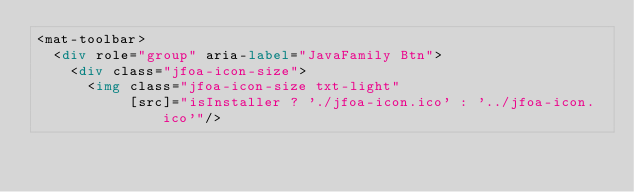<code> <loc_0><loc_0><loc_500><loc_500><_HTML_><mat-toolbar>
  <div role="group" aria-label="JavaFamily Btn">
    <div class="jfoa-icon-size">
      <img class="jfoa-icon-size txt-light"
           [src]="isInstaller ? './jfoa-icon.ico' : '../jfoa-icon.ico'"/></code> 